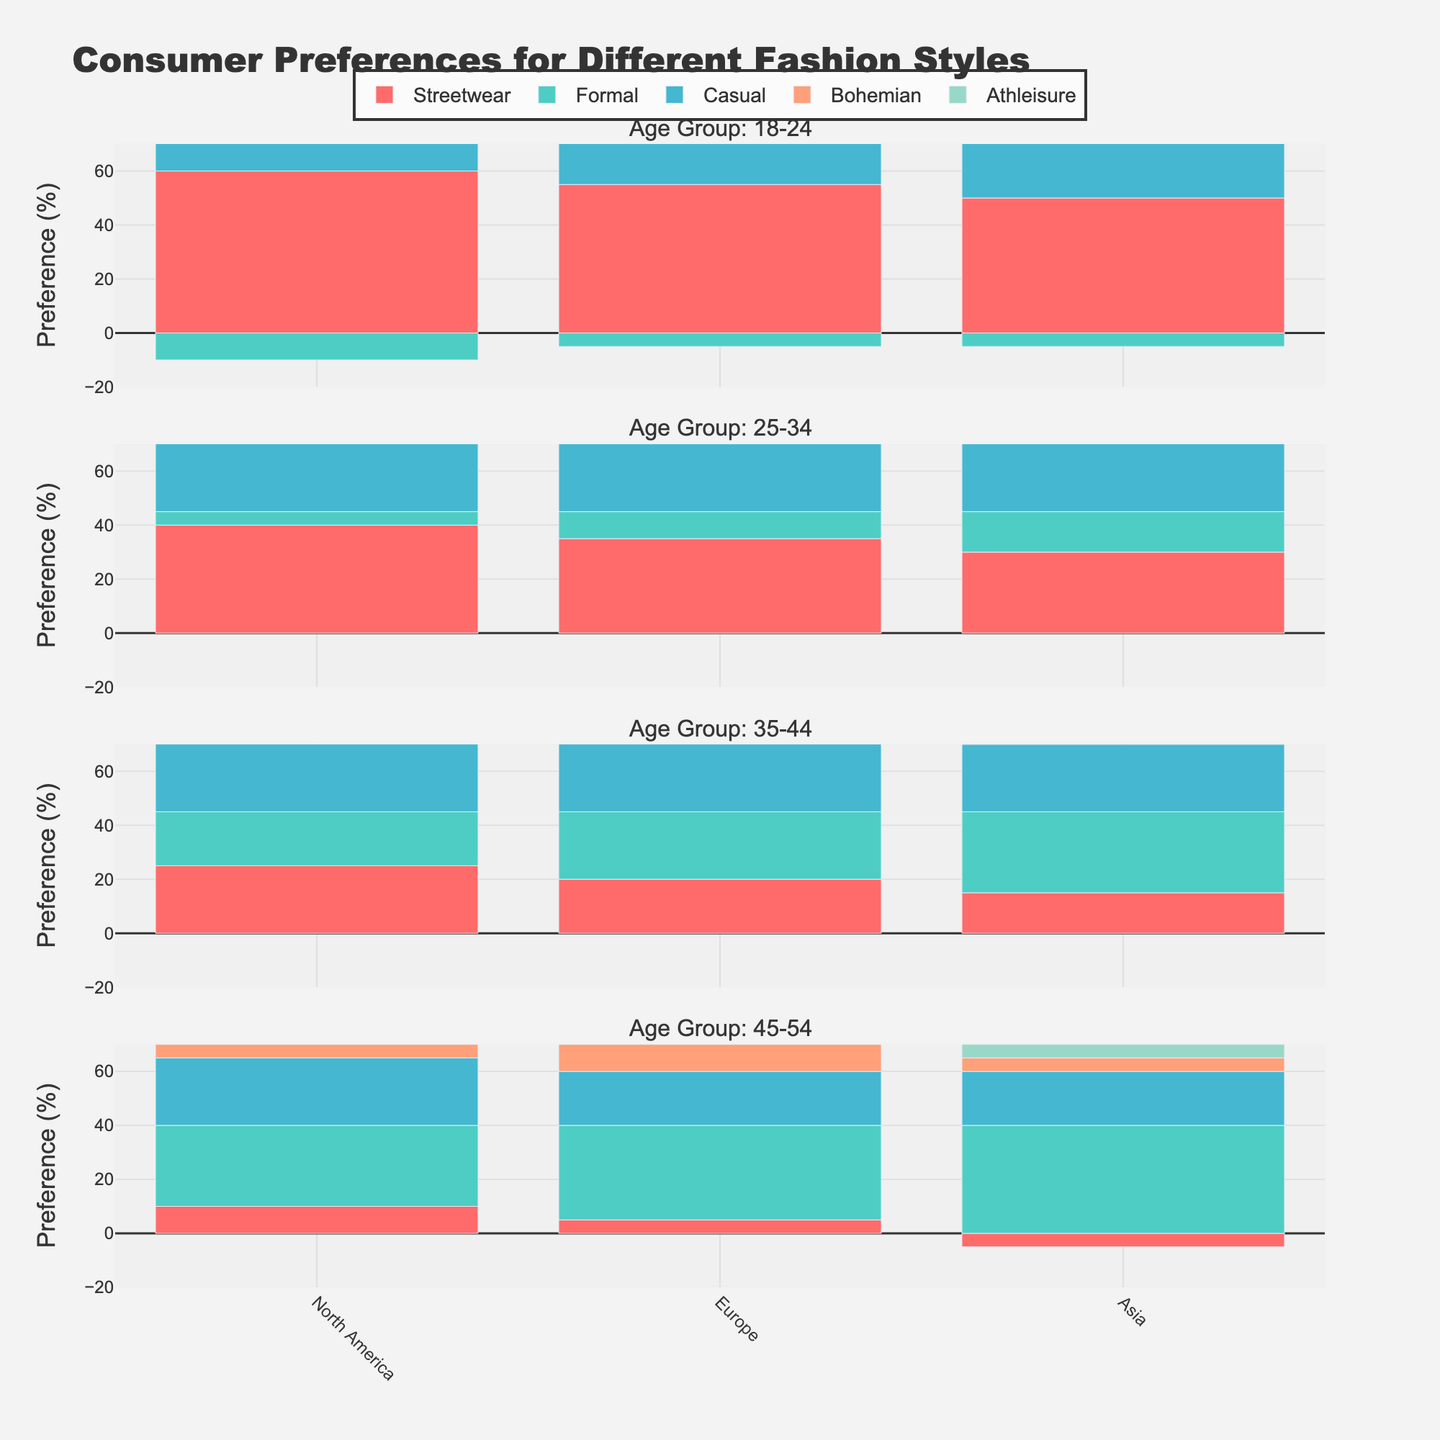Which age group shows the highest preference for Streetwear in Europe? To determine this, examine the bars representing Streetwear in the European region across different age groups. The 18-24 age group has the highest positive bar for Streetwear compared to other age groups.
Answer: 18-24 In North America, what is the difference in preference between Athleisure for the 18-24 age group and the 45-54 age group? Observe the Athleisure bars for North America in both the 18-24 and 45-54 age groups. The preference is 25% for the 18-24 group and 10% for the 45-54 group. The difference is 25 - 10.
Answer: 15% Which location shows the highest preference for Bohemian style across all age groups? Look at the Bohemian bars across different locations for all age groups. The highest positive value for Bohemian is 15%, observed in the 18-24 age group in Asia.
Answer: Asia Compare the preference for Formal wear among the 35-44 age group across all locations. Which location has the least preference? Examine the Formal wear bars for the 35-44 age group in each location. The least preference is in North America with a value of 20%.
Answer: North America What's the total preference percentage for Casual wear in Asia for all age groups combined? Sum up the Casual wear values across all age groups in Asia: 30% (18-24) + 40% (25-34) + 25% (35-44) + 20% (45-54). Total: 30 + 40 + 25 + 20.
Answer: 115% Between Europe and North America, which location shows a higher variance in the preference for Formal wear across all age groups? Evaluate the range of values for Formal wear in both locations. North America's values range from -10% to 30%, with a spread of 40%. Europe's values range from -5% to 35%, with a spread of 40%. Both have the same variance.
Answer: Equal For the age group 25-34, how does the preference for Casual wear in Europe compare to that in Asia? Compare the bars for Casual wear (35% in Europe and 40% in Asia) within the 25-34 age group. Asia has a 5% higher preference.
Answer: Asia Based on the visualization, what is the trend of Streetwear preference as age increases in North America? Analyze the Streetwear bars across increasing age groups in North America. The preference decreases from 60% (18-24) to 40% (25-34), 25% (35-44), and 10% (45-54). The trend is a consistent decline.
Answer: Declining In the 45-54 age group, which location has the most balanced preference (least variation) among the styles represented? Assess the bars for the 45-54 age group across all styles in each location. Europe shows the most balanced preference with values close to each other: 5% (Streetwear), 35% (Formal), 20% (Casual), 10% (Bohemian), and 15% (Athleisure).
Answer: Europe 